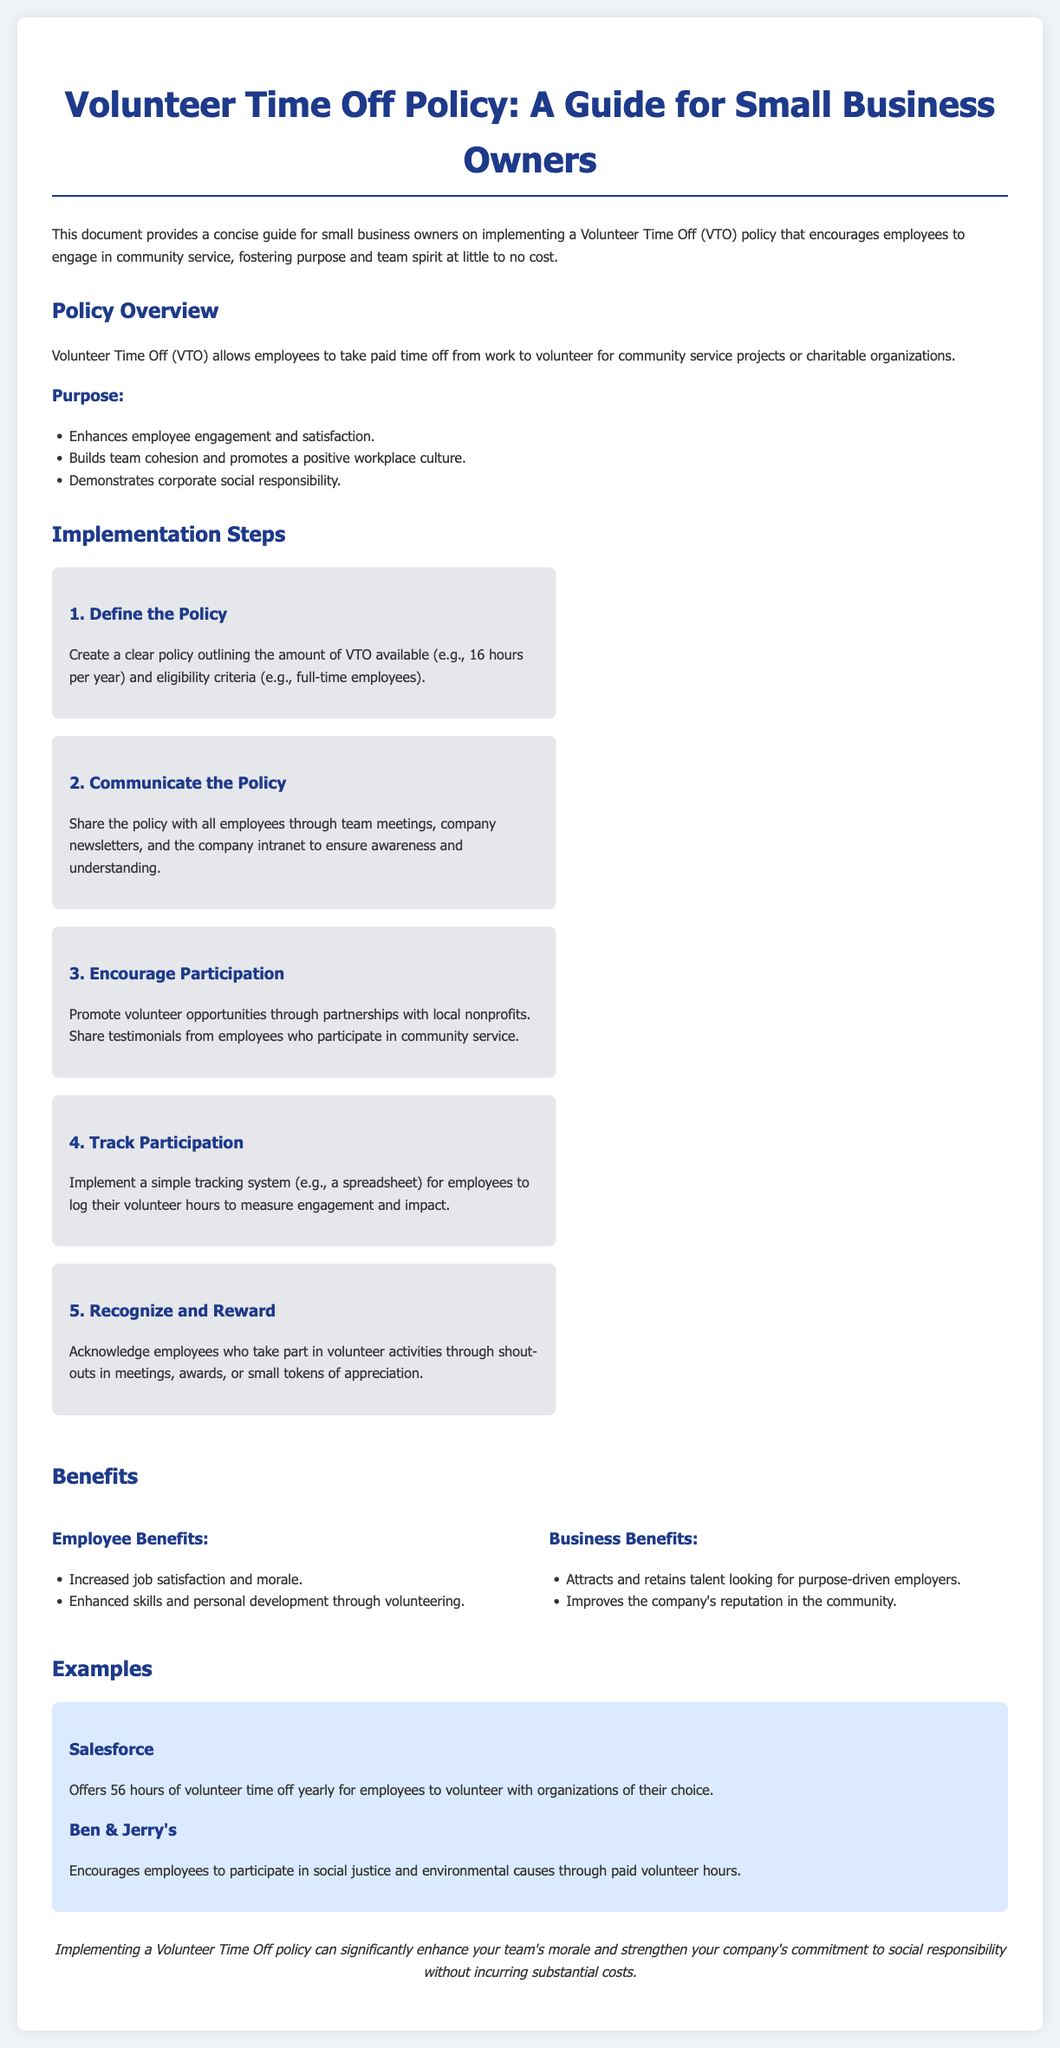what is the amount of VTO available per year? The policy mentions that employees are entitled to a certain amount of Volunteer Time Off, specifically outlining 16 hours available per year.
Answer: 16 hours what type of employees are eligible for VTO? The document states that eligibility criteria for VTO includes full-time employees.
Answer: full-time employees what are two purposes of implementing a VTO policy? The document lists several purposes, specifically enhancing employee engagement and building team cohesion, as key reasons for VTO policy.
Answer: employee engagement and team cohesion which company offers 56 hours of volunteer time off yearly? The examples section mentions that Salesforce provides 56 hours of volunteer time off for employees.
Answer: Salesforce what is a benefit for employees participating in volunteer activities? One of the stated benefits for employees is increased job satisfaction and morale, as highlighted in the benefits section.
Answer: increased job satisfaction how many implementation steps are outlined in the document? The implementation steps section of the document lists a total of five specific steps for implementing the VTO policy.
Answer: five what should be done to promote volunteer opportunities? The policy document advises that businesses should encourage participation through partnerships with local nonprofits.
Answer: partnerships with local nonprofits how are employees recognized for participating in volunteer activities? Recognition can take the form of shout-outs in meetings, awards, or small tokens of appreciation, as mentioned in the document.
Answer: shout-outs in meetings, awards, or small tokens of appreciation 